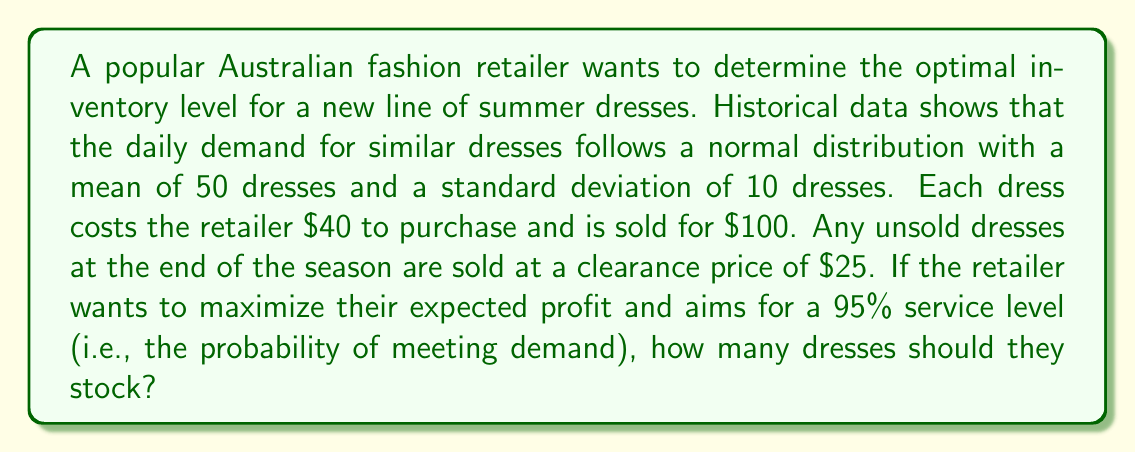Could you help me with this problem? To solve this problem, we'll use the concept of the newsvendor model and the properties of the normal distribution.

1. First, we need to calculate the critical fractile (CF):
   $$ CF = \frac{p - c}{p - s} $$
   Where:
   $p$ = selling price = $100
   $c$ = cost price = $40
   $s$ = salvage value = $25

   $$ CF = \frac{100 - 40}{100 - 25} = \frac{60}{75} = 0.8 $$

2. The service level is given as 95%, which corresponds to a z-score of 1.645 in the standard normal distribution.

3. We can calculate the optimal inventory level (Q*) using the formula:
   $$ Q* = \mu + z\sigma $$
   Where:
   $\mu$ = mean demand = 50
   $\sigma$ = standard deviation of demand = 10
   $z$ = z-score corresponding to the critical fractile = 1.645

   $$ Q* = 50 + 1.645 * 10 = 66.45 $$

4. Since we can't stock fractional dresses, we round up to the nearest whole number.

Therefore, the optimal inventory level is 67 dresses.

Note: The service level (95%) given in the question is higher than the critical fractile (80%) we calculated. This means the retailer is willing to overstock to meet customer demand, which aligns with the high-end nature of fashion retail where stockouts can be particularly costly in terms of customer satisfaction and brand image.
Answer: The optimal inventory level for the retailer is 67 dresses. 